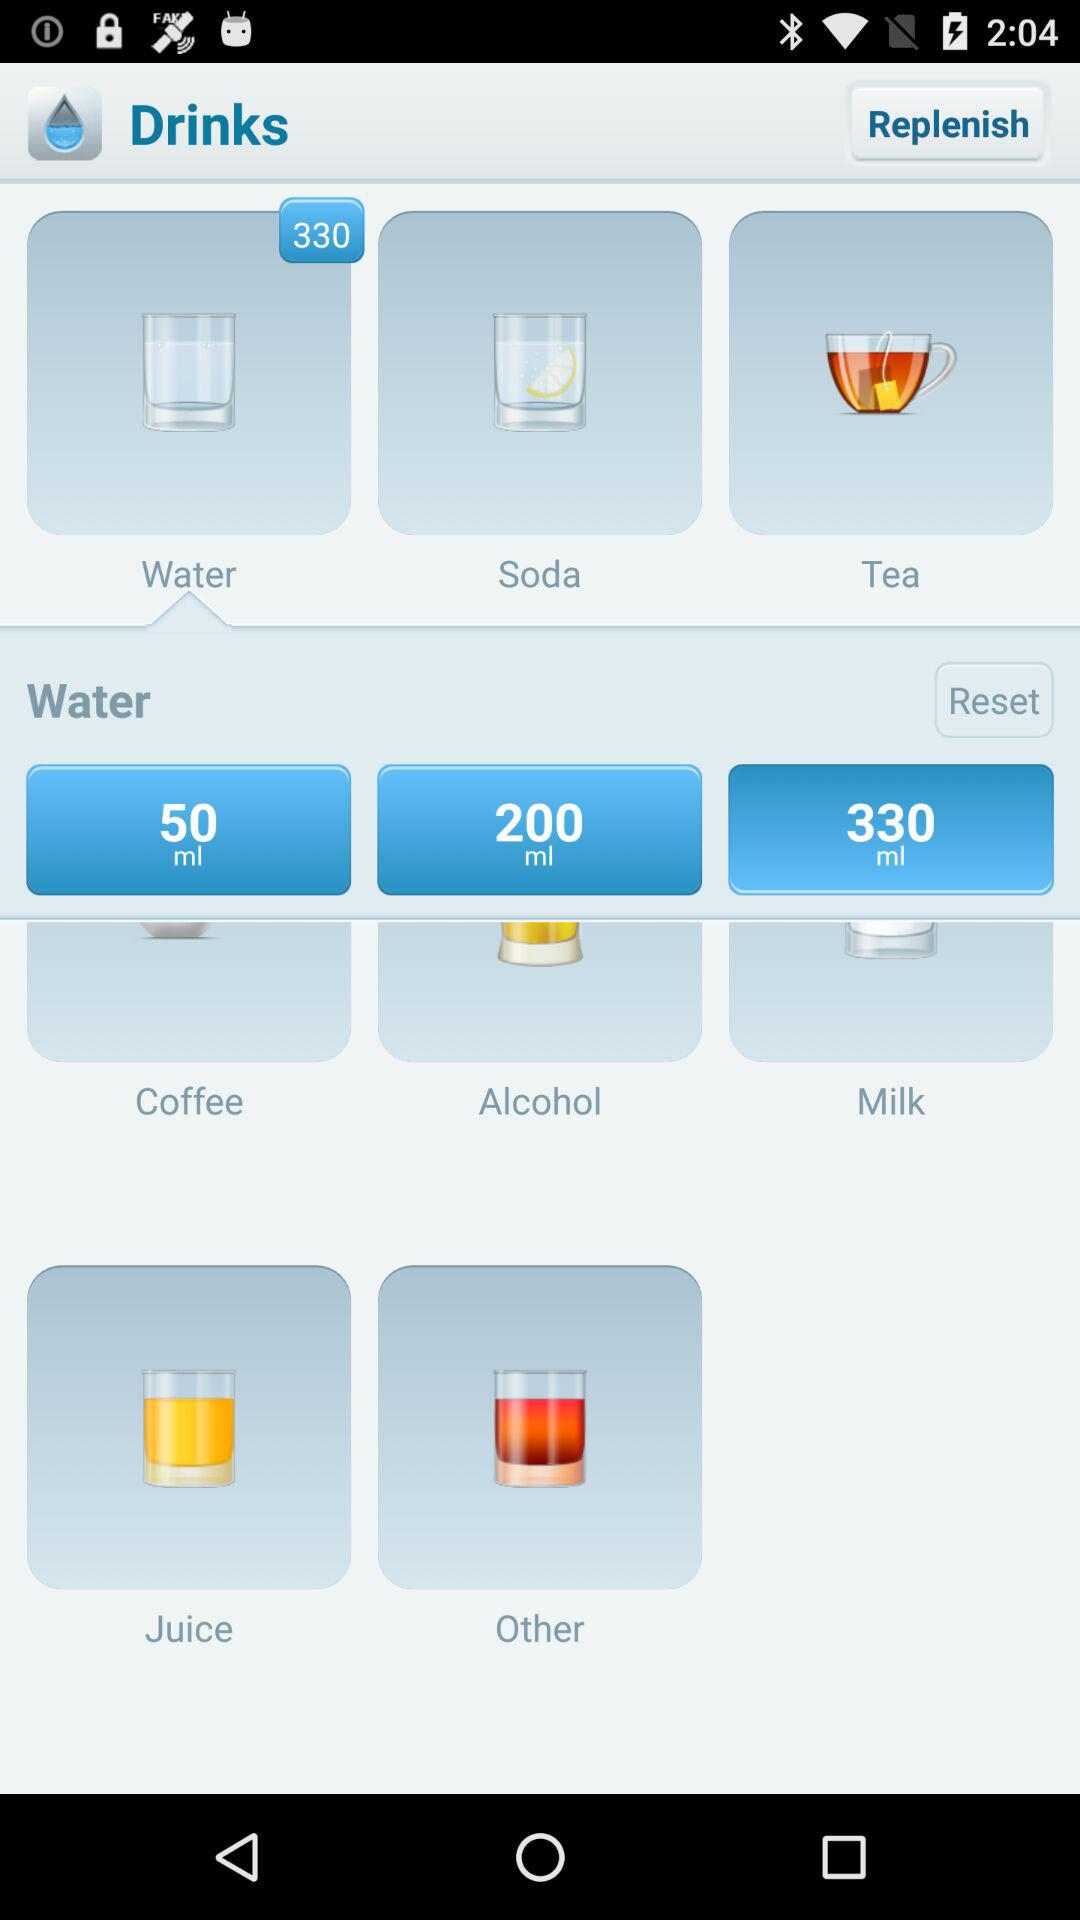What is the quantity of coffee? The quantity of coffee is 50 ml. 